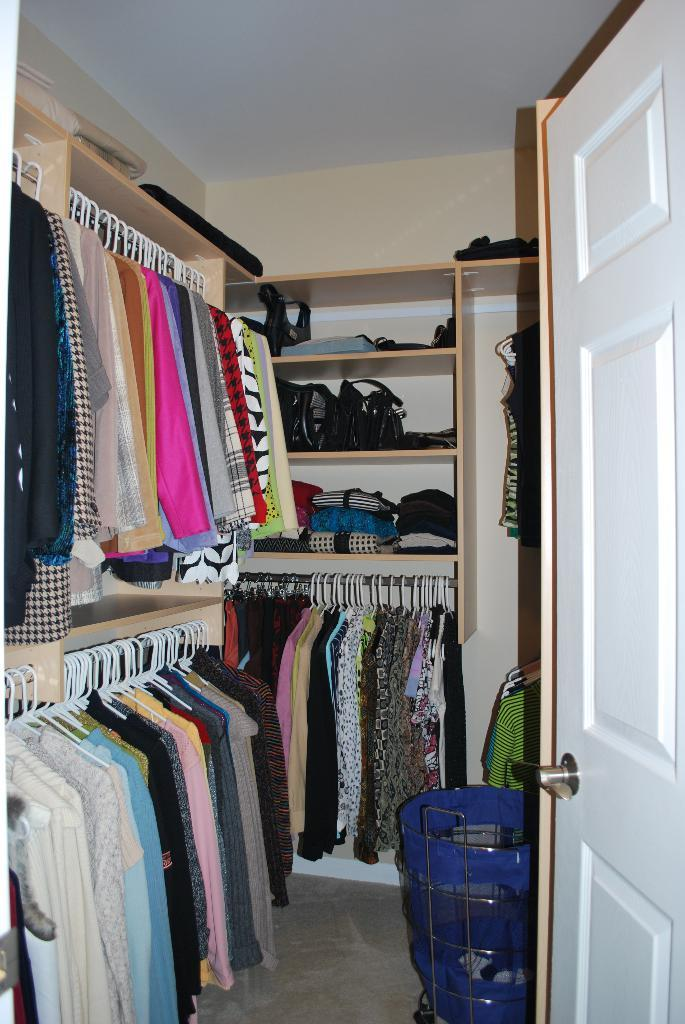What is one of the main features of the image? There is a door in the image. What can be seen under the door in the image? The ground is visible in the image. What items are related to clothing in the image? There are clothes in the image. What type of storage is present in the image? There are shelves in the image. What type of items are used for carrying or holding things in the image? There are bags in the image. What other objects can be seen in the image? There are other objects in the image. What can be seen in the background of the image? There is a wall and a roof in the background of the image. How many eggs are being cracked on the door in the image? There are no eggs or cracking sounds in the image; it only features a door, ground, clothes, shelves, bags, other objects, a wall, and a roof. 